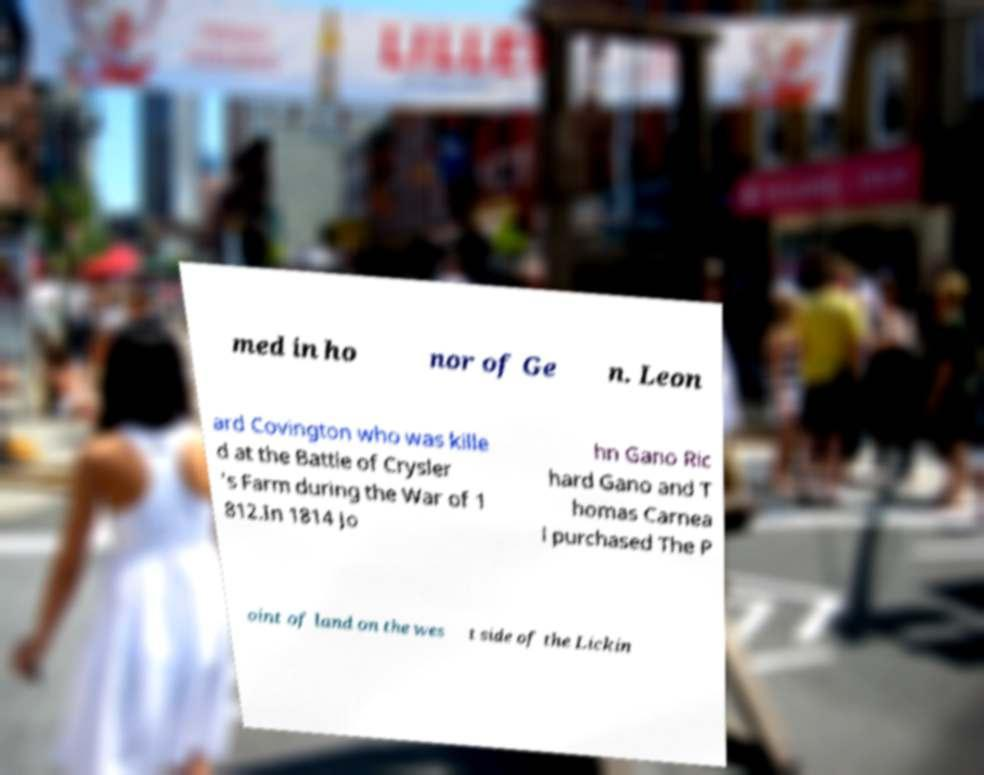Can you accurately transcribe the text from the provided image for me? med in ho nor of Ge n. Leon ard Covington who was kille d at the Battle of Crysler 's Farm during the War of 1 812.In 1814 Jo hn Gano Ric hard Gano and T homas Carnea l purchased The P oint of land on the wes t side of the Lickin 